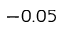Convert formula to latex. <formula><loc_0><loc_0><loc_500><loc_500>- 0 . 0 5</formula> 